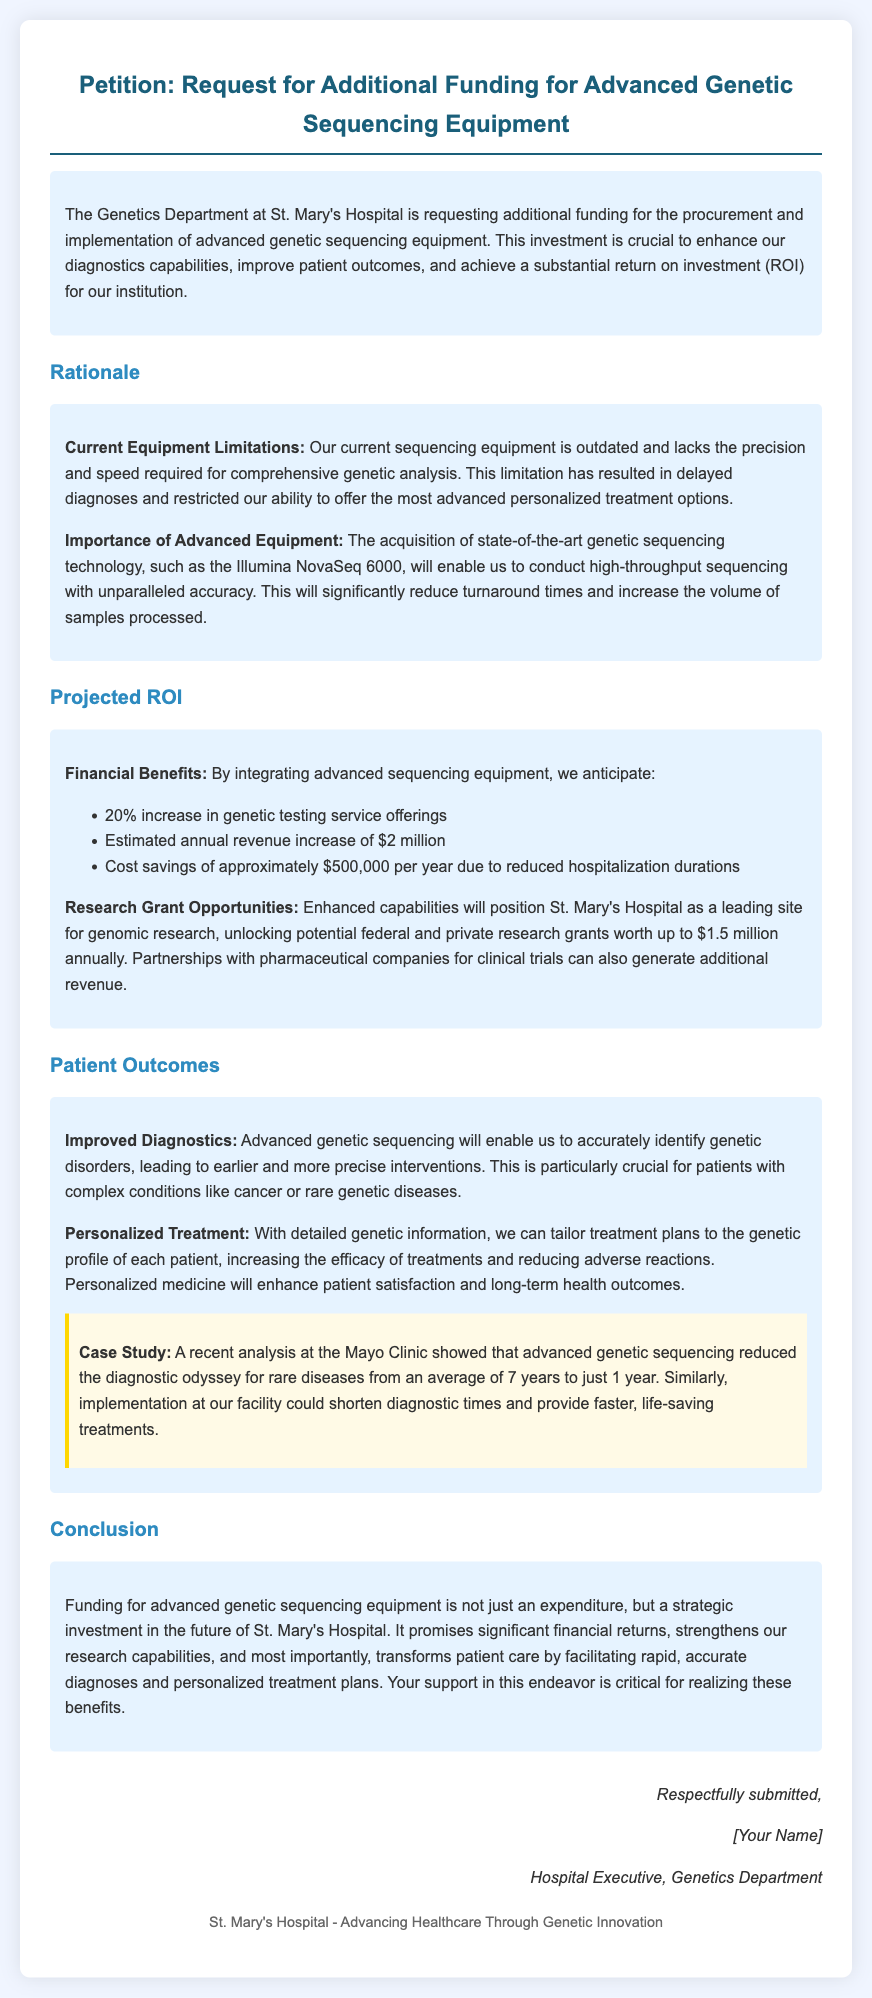What is the title of the petition? The title of the petition is stated at the beginning of the document.
Answer: Petition: Request for Additional Funding for Advanced Genetic Sequencing Equipment What hospital is requesting funding? The name of the hospital is mentioned in the introduction of the document.
Answer: St. Mary's Hospital What is the projected annual revenue increase from the new equipment? The projected annual revenue increase is provided in the section discussing financial benefits.
Answer: $2 million What is the estimated annual cost savings due to reduced hospitalization durations? The document states the estimated annual cost savings in the projected ROI section.
Answer: $500,000 How much could potential federal and private research grants be worth annually? The document quantifies the potential research grant opportunities in the projected ROI section.
Answer: $1.5 million What is one of the conditions that advanced genetic sequencing aims to improve diagnostics for? The document outlines specific conditions that will benefit from improved diagnostics in the patient outcomes section.
Answer: Cancer What was reduced from an average of 7 years to just 1 year according to the case study? The case study includes a statistic related to diagnostic times for rare diseases.
Answer: Diagnostic odyssey What is the name of the advanced genetic sequencing technology mentioned? The document specifies the name of the advanced sequencing technology under the importance section.
Answer: Illumina NovaSeq 6000 What is the purpose of the petition? The purpose of the petition is articulated in the introduction of the document.
Answer: Request additional funding for advanced genetic sequencing equipment 